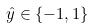Convert formula to latex. <formula><loc_0><loc_0><loc_500><loc_500>\hat { y } \in \{ - 1 , 1 \}</formula> 